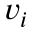<formula> <loc_0><loc_0><loc_500><loc_500>v _ { i }</formula> 